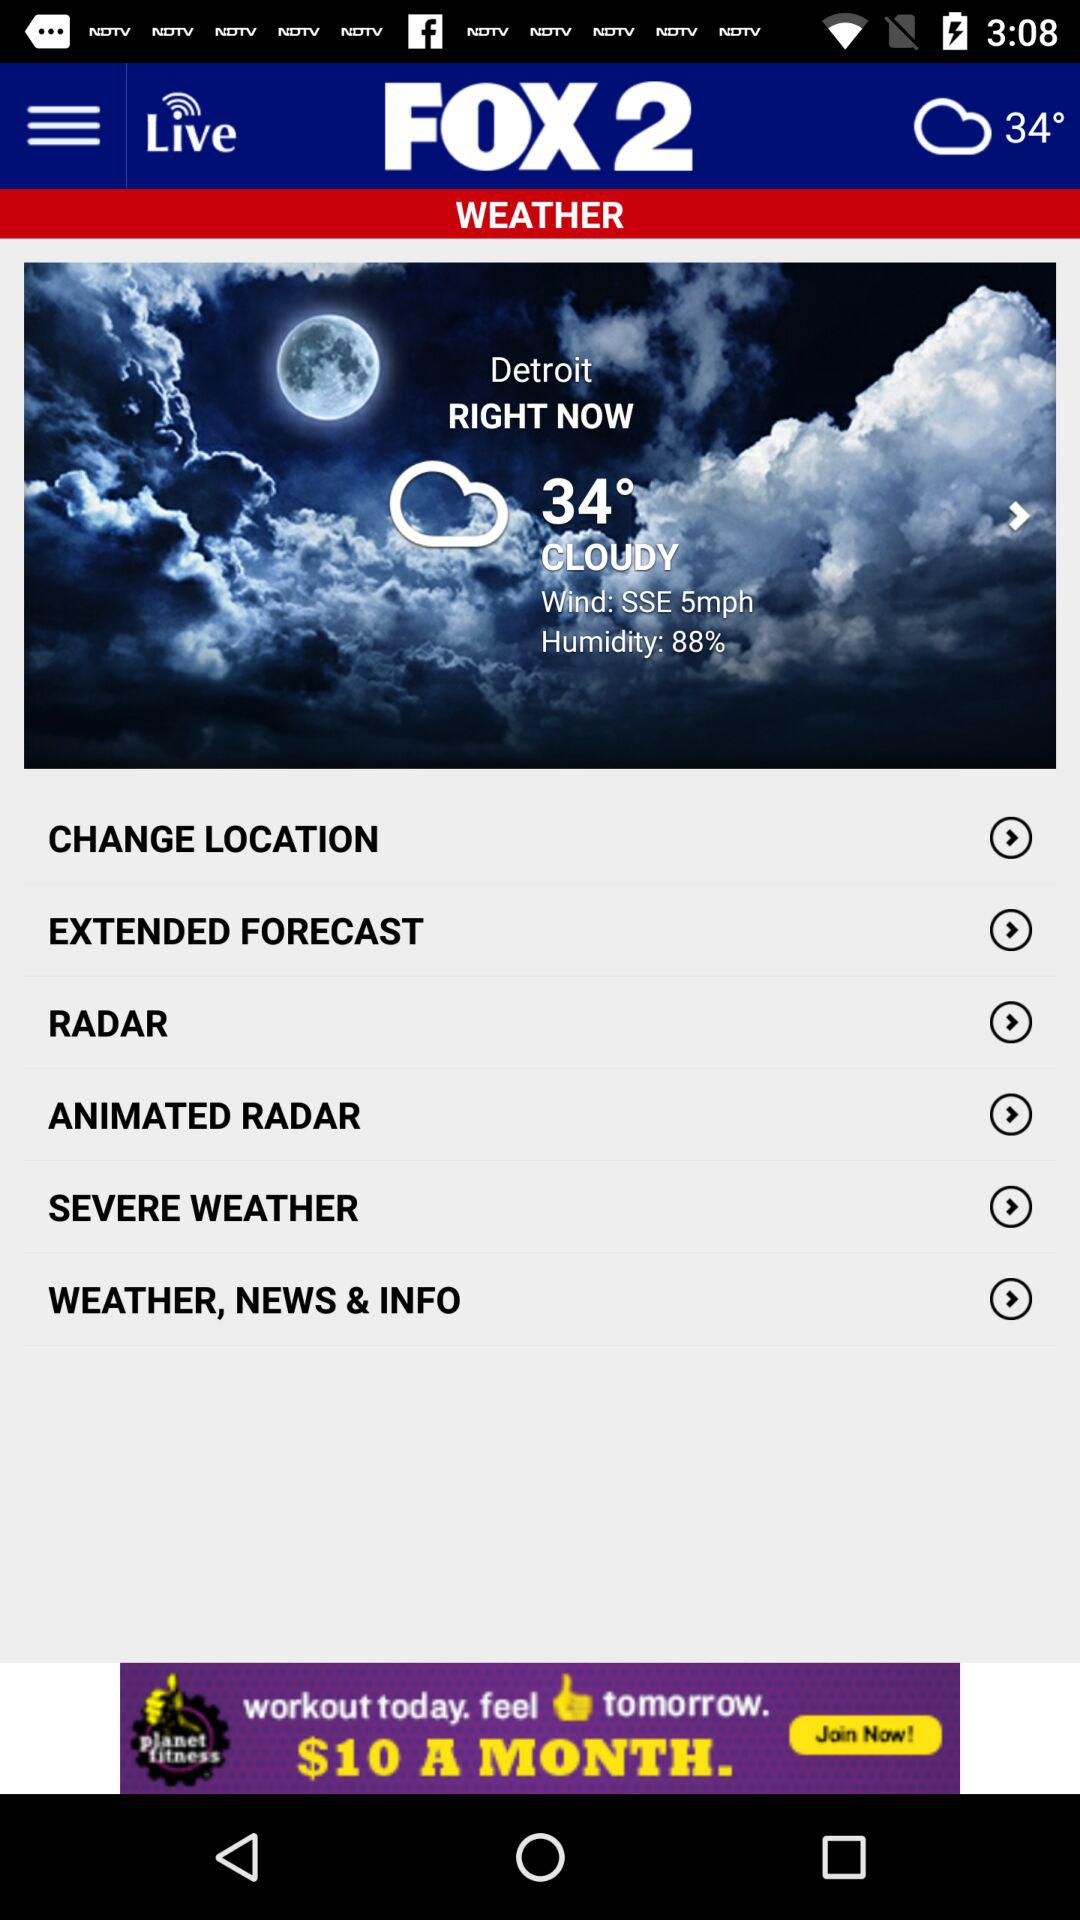What is the speed of the wind? The speed of the wind is 5mph. 